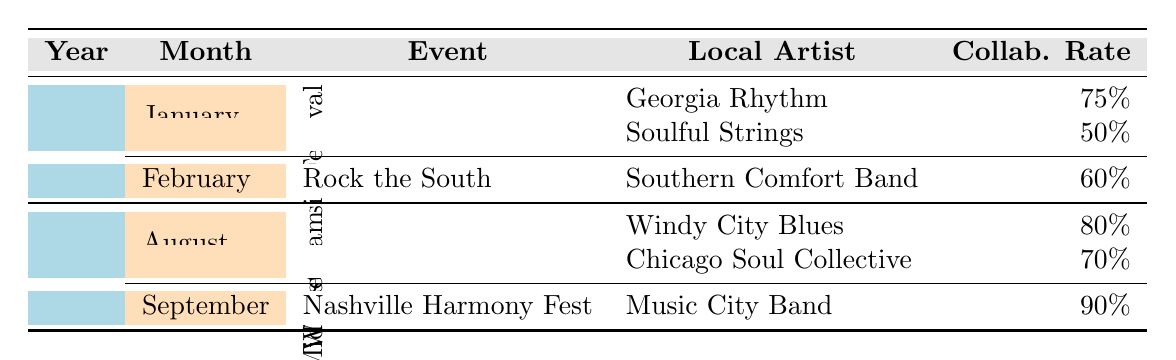What is the collaboration rate with Georgia Rhythm? The table indicates the collaboration rate with Georgia Rhythm listed under the January event of 2023, which is 75%.
Answer: 75% Which event in 2022 had the highest collaboration rate? By inspecting the collaboration rates for events in 2022, the Nashville Harmony Fest has a collaboration rate of 90%, which is the highest among all events listed in that year.
Answer: 90% How many local artists collaborated with The Black Crowes in February 2023? In February 2023, there is one local artist listed (Southern Comfort Band) under the event Rock the South, so the answer is one artist.
Answer: 1 What is the average collaboration rate for The Black Crowes in 2022? The collaboration rates for 2022 are 80% (Midwest Jam) + 70% (Midwest Jam) + 90% (Nashville Harmony Fest) = 240%. There are three collaboration instances, thus the average is 240% / 3 = 80%.
Answer: 80% Is there a local artist with a collaboration rate of 50%? Yes, the table shows that Soulful Strings collaborated with The Black Crowes at a rate of 50%.
Answer: Yes Which month in 2023 had more collaboration rates, January or February? January 2023 has two collaborations (75% and 50%), while February has one collaboration (60%). Calculating the overall collaboration rates, January has an average of (75% + 50%) / 2 = 62.5% and February's rate is directly 60%. January has a higher average collaboration rate.
Answer: January What is the total number of collaboration instances across all events in 2022? In 2022, there are three collaboration instances from the Midwest Jam event (two artists) and one instance from the Nashville Harmony Fest (one artist), adding to a total of three collaboration instances in that year.
Answer: 3 Which local artist had the lowest collaboration rate with The Black Crowes? Among the local artists listed, the lowest collaboration rate is with Soulful Strings at 50%.
Answer: Soulful Strings 